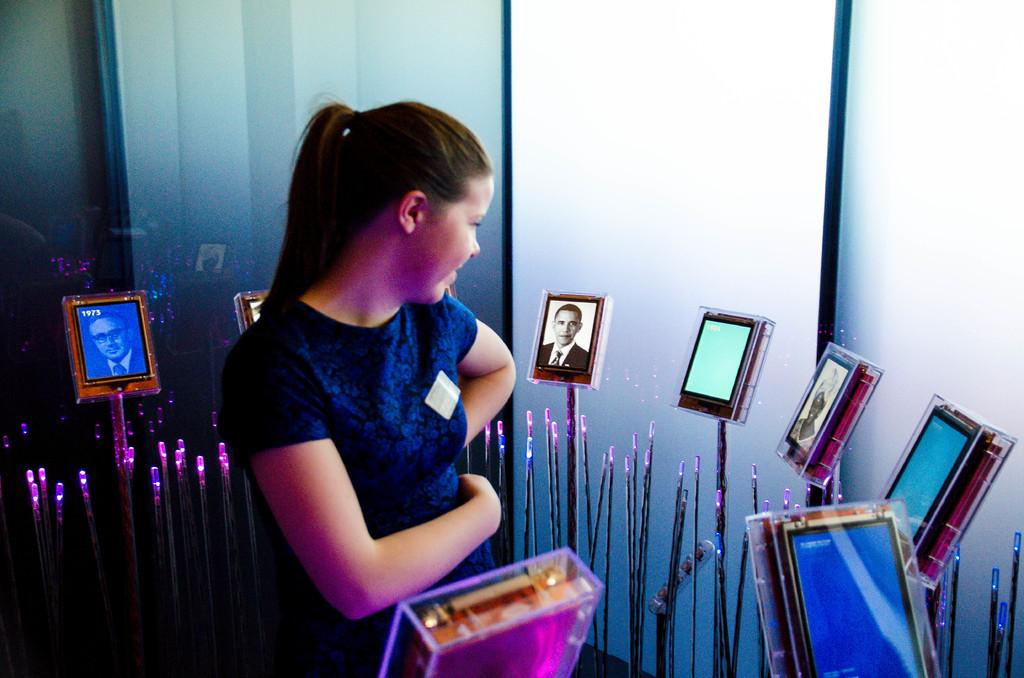What is the main subject of the image? There is a person standing in the image. What can be seen in the boxes in the image? There are photos in boxes in the image. What else is present in the image besides the person and the boxes? There are objects in the image. What can be seen in the background of the image? There is a wall in the background of the image. Where is the fire hydrant located in the image? There is no fire hydrant present in the image. What type of yoke is being used by the person in the image? There is no yoke present in the image, and the person is not using any yoke. 